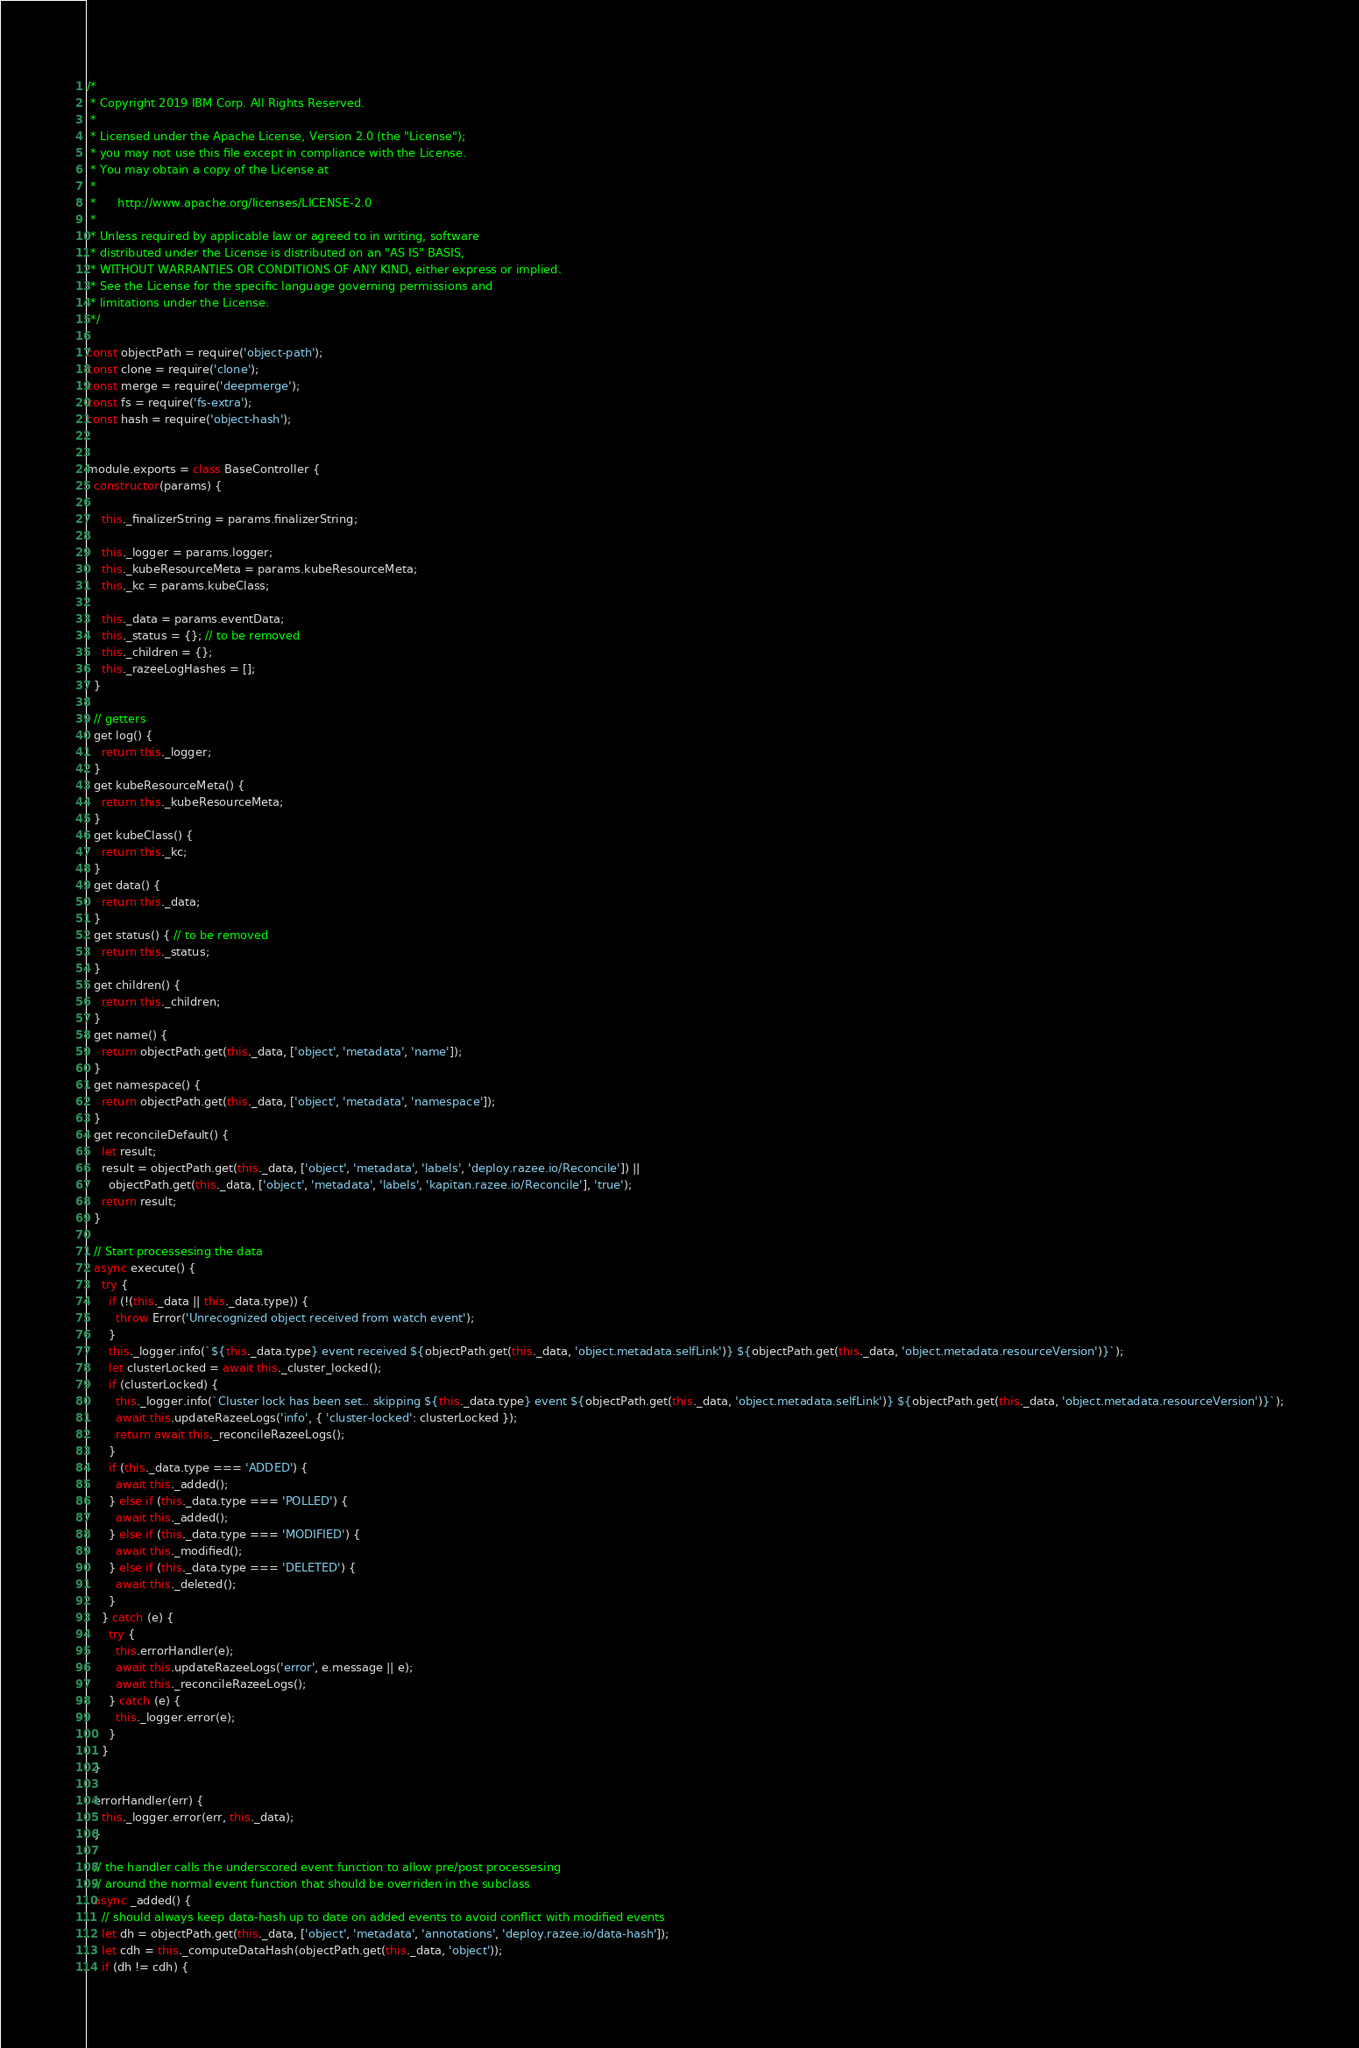Convert code to text. <code><loc_0><loc_0><loc_500><loc_500><_JavaScript_>/*
 * Copyright 2019 IBM Corp. All Rights Reserved.
 *
 * Licensed under the Apache License, Version 2.0 (the "License");
 * you may not use this file except in compliance with the License.
 * You may obtain a copy of the License at
 *
 *      http://www.apache.org/licenses/LICENSE-2.0
 *
 * Unless required by applicable law or agreed to in writing, software
 * distributed under the License is distributed on an "AS IS" BASIS,
 * WITHOUT WARRANTIES OR CONDITIONS OF ANY KIND, either express or implied.
 * See the License for the specific language governing permissions and
 * limitations under the License.
 */

const objectPath = require('object-path');
const clone = require('clone');
const merge = require('deepmerge');
const fs = require('fs-extra');
const hash = require('object-hash');


module.exports = class BaseController {
  constructor(params) {

    this._finalizerString = params.finalizerString;

    this._logger = params.logger;
    this._kubeResourceMeta = params.kubeResourceMeta;
    this._kc = params.kubeClass;

    this._data = params.eventData;
    this._status = {}; // to be removed
    this._children = {};
    this._razeeLogHashes = [];
  }

  // getters
  get log() {
    return this._logger;
  }
  get kubeResourceMeta() {
    return this._kubeResourceMeta;
  }
  get kubeClass() {
    return this._kc;
  }
  get data() {
    return this._data;
  }
  get status() { // to be removed
    return this._status;
  }
  get children() {
    return this._children;
  }
  get name() {
    return objectPath.get(this._data, ['object', 'metadata', 'name']);
  }
  get namespace() {
    return objectPath.get(this._data, ['object', 'metadata', 'namespace']);
  }
  get reconcileDefault() {
    let result;
    result = objectPath.get(this._data, ['object', 'metadata', 'labels', 'deploy.razee.io/Reconcile']) ||
      objectPath.get(this._data, ['object', 'metadata', 'labels', 'kapitan.razee.io/Reconcile'], 'true');
    return result;
  }

  // Start processesing the data
  async execute() {
    try {
      if (!(this._data || this._data.type)) {
        throw Error('Unrecognized object received from watch event');
      }
      this._logger.info(`${this._data.type} event received ${objectPath.get(this._data, 'object.metadata.selfLink')} ${objectPath.get(this._data, 'object.metadata.resourceVersion')}`);
      let clusterLocked = await this._cluster_locked();
      if (clusterLocked) {
        this._logger.info(`Cluster lock has been set.. skipping ${this._data.type} event ${objectPath.get(this._data, 'object.metadata.selfLink')} ${objectPath.get(this._data, 'object.metadata.resourceVersion')}`);
        await this.updateRazeeLogs('info', { 'cluster-locked': clusterLocked });
        return await this._reconcileRazeeLogs();
      }
      if (this._data.type === 'ADDED') {
        await this._added();
      } else if (this._data.type === 'POLLED') {
        await this._added();
      } else if (this._data.type === 'MODIFIED') {
        await this._modified();
      } else if (this._data.type === 'DELETED') {
        await this._deleted();
      }
    } catch (e) {
      try {
        this.errorHandler(e);
        await this.updateRazeeLogs('error', e.message || e);
        await this._reconcileRazeeLogs();
      } catch (e) {
        this._logger.error(e);
      }
    }
  }

  errorHandler(err) {
    this._logger.error(err, this._data);
  }

  // the handler calls the underscored event function to allow pre/post processesing
  // around the normal event function that should be overriden in the subclass
  async _added() {
    // should always keep data-hash up to date on added events to avoid conflict with modified events
    let dh = objectPath.get(this._data, ['object', 'metadata', 'annotations', 'deploy.razee.io/data-hash']);
    let cdh = this._computeDataHash(objectPath.get(this._data, 'object'));
    if (dh != cdh) {</code> 